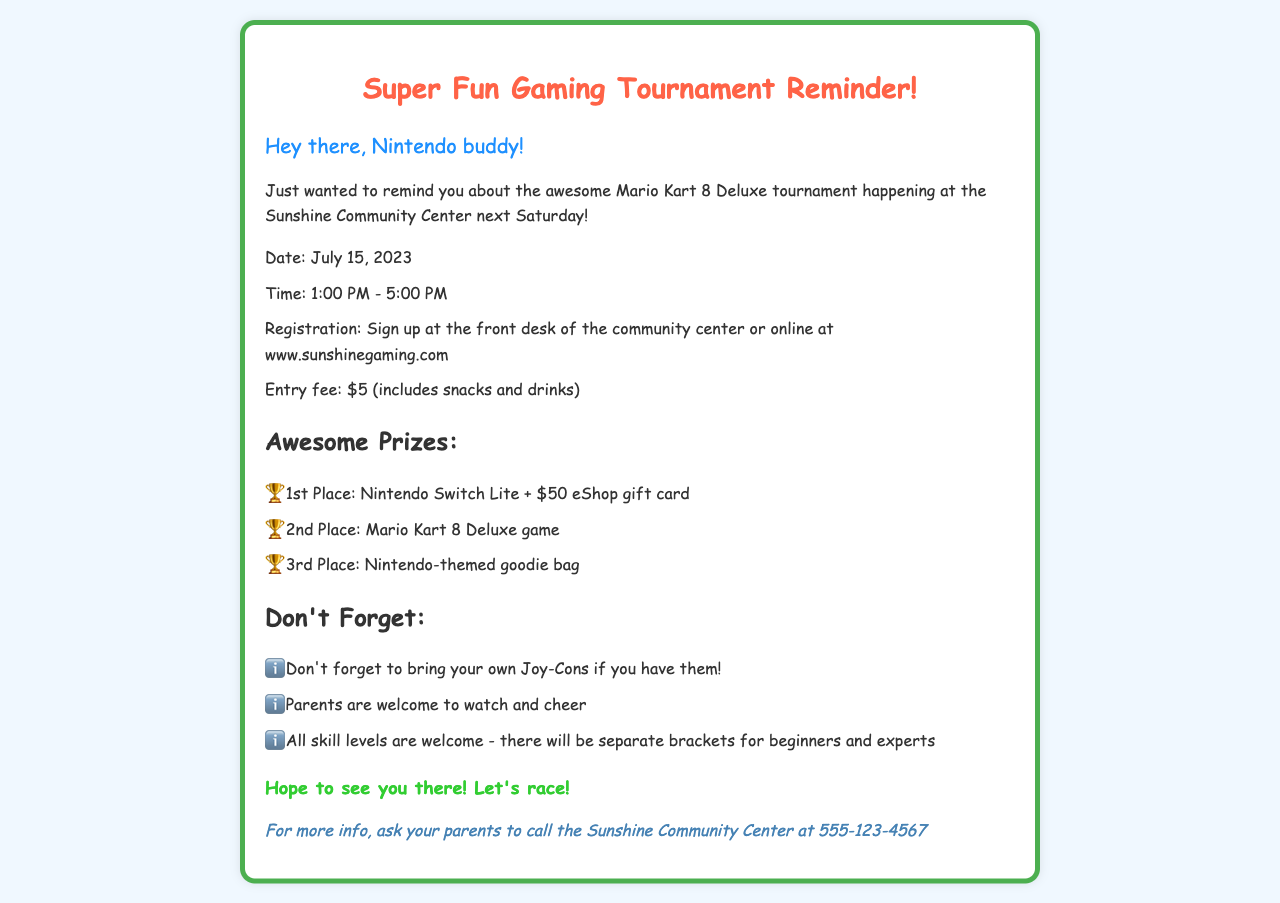What game is being played in the tournament? The main game featured in the tournament is Mario Kart 8 Deluxe, as mentioned in the document.
Answer: Mario Kart 8 Deluxe What is the entry fee for the tournament? The document states that the entry fee is $5, which also includes snacks and drinks.
Answer: $5 When is the gaming tournament scheduled? The date of the gaming tournament is provided in the document as July 15, 2023.
Answer: July 15, 2023 What are the prizes for the winners? The document lists several prizes, including a Nintendo Switch Lite for 1st place, which highlights the competitive aspect of the tournament.
Answer: Nintendo Switch Lite + $50 eShop gift card Where can participants register for the tournament? The document specifies that registration can be done at the front desk of the community center or online at a given website, providing important logistical information.
Answer: www.sunshinegaming.com What should participants bring to the tournament? The document reminds participants not to forget to bring their own Joy-Cons if they have them.
Answer: Joy-Cons Is there a limit on participant skill levels? The document mentions that all skill levels are welcome and that there will be separate brackets for beginners and experts, promoting inclusivity.
Answer: All skill levels are welcome 